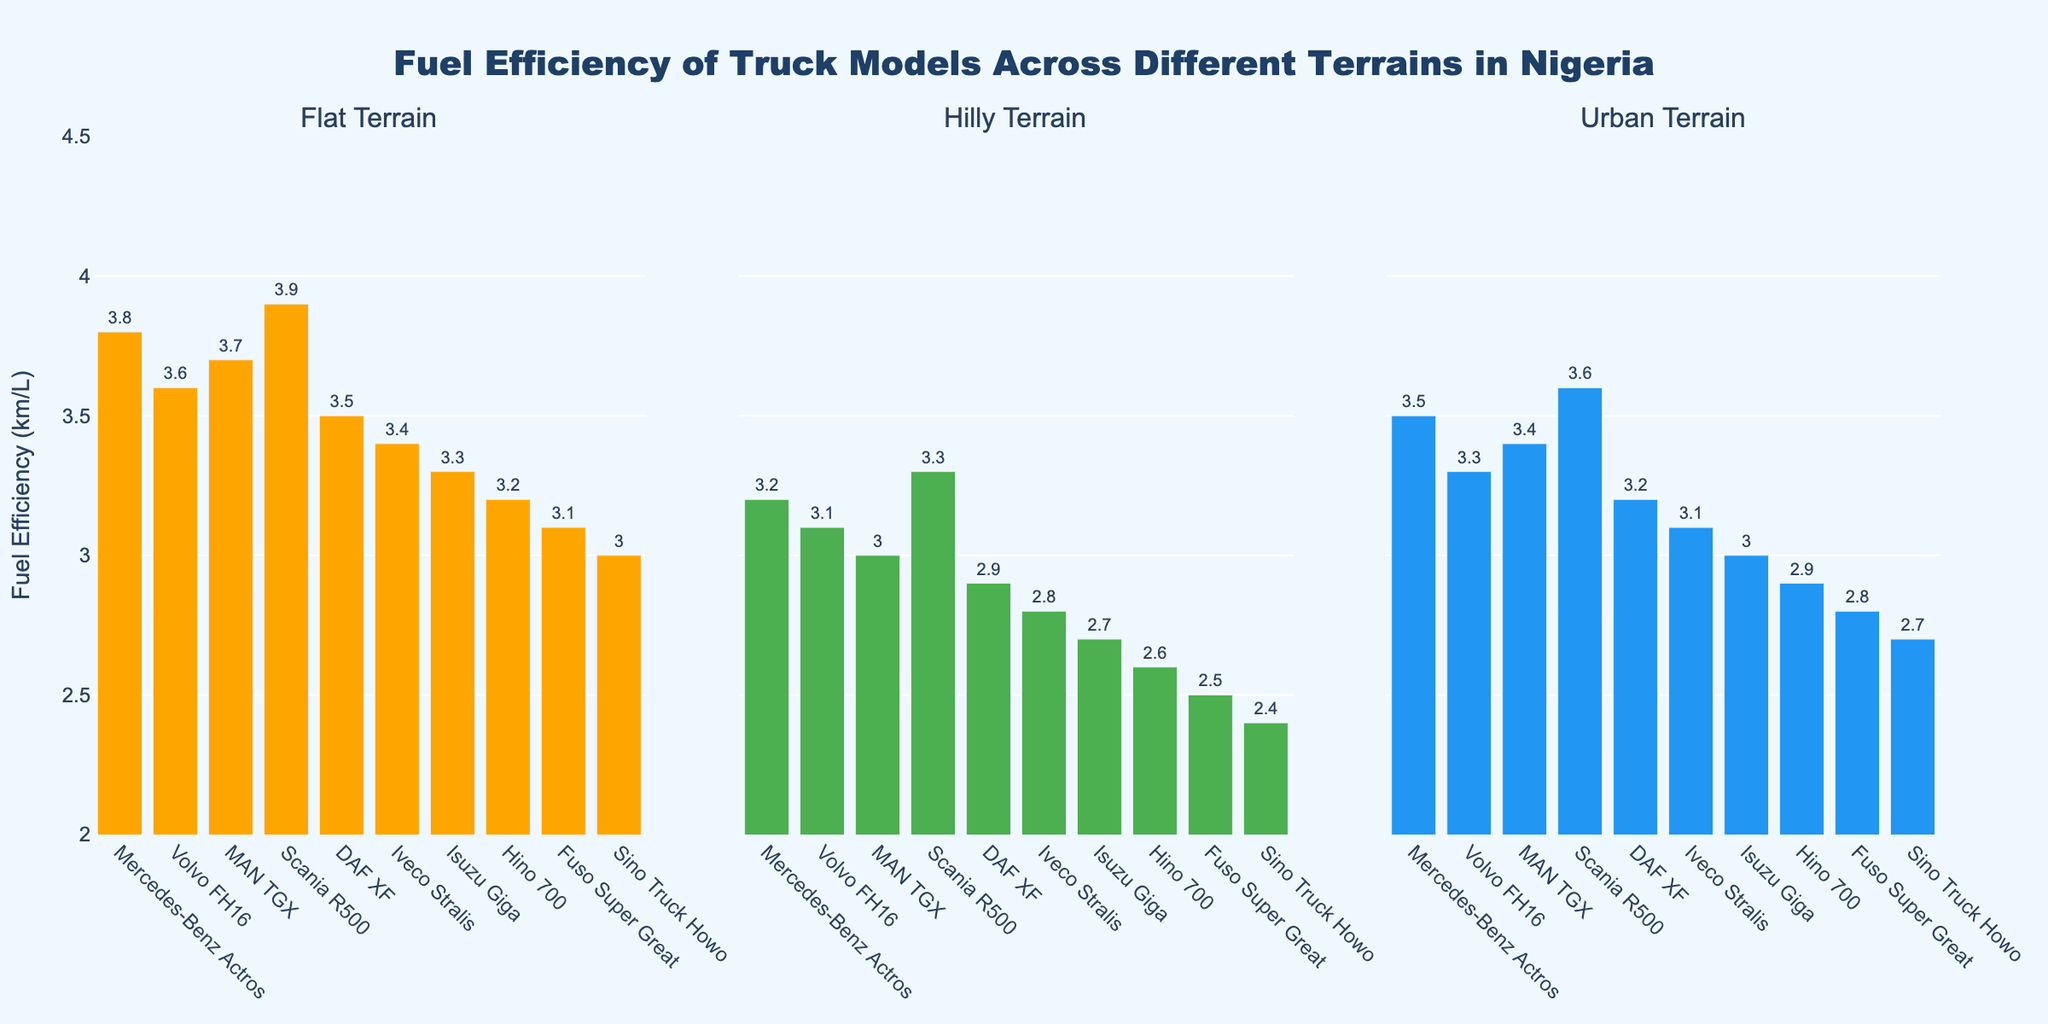What's the fuel efficiency of the Mercedes-Benz Actros on flat terrain? The bar for the Mercedes-Benz Actros under 'Flat Terrain' shows a value of 3.8 km/L.
Answer: 3.8 km/L Which truck model has the highest fuel efficiency on hilly terrain? The tallest bar in the 'Hilly Terrain' subplot belongs to the Scania R500, which has a fuel efficiency of 3.3 km/L.
Answer: Scania R500 What is the difference in fuel efficiency between Fuso Super Great and Sino Truck Howo on flat terrain? The Fuso Super Great has a fuel efficiency of 3.1 km/L and the Sino Truck Howo has 3.0 km/L, so the difference is 3.1 - 3.0.
Answer: 0.1 km/L Which terrain shows the least variation in fuel efficiencies among all truck models? All three subplots show bars of various heights. Comparing the bar heights across subplots, the 'Urban Terrain' shows a narrower range (from 2.7 to 3.6 km/L), indicating the least variation.
Answer: Urban Terrain On which terrain does the Volvo FH16 have the lowest fuel efficiency? The bar for the Volvo FH16 is lowest in the 'Hilly Terrain' subplot at 3.1 km/L, compared to its values in flat and urban terrains.
Answer: Hilly Terrain Are there any truck models with a consistent decrease in fuel efficiency from flat to hilly to urban terrains? Reviewing the bars across all subplots, the Fuso Super Great shows a consistent decrease in fuel efficiency from flat (3.1 km/L) to hilly (2.5 km/L) to urban (2.8 km/L) terrains.
Answer: Yes, Fuso Super Great What's the average fuel efficiency of the MAN TGX across all terrains? The fuel efficiencies for the MAN TGX are 3.7 (flat), 3.0 (hilly), and 3.4 (urban). The average is (3.7 + 3.0 + 3.4) / 3.
Answer: 3.37 km/L Which truck model performs best on urban terrain? The tallest bar in the 'Urban Terrain' subplot belongs to the Scania R500, indicating it has the highest fuel efficiency on urban terrain at 3.6 km/L.
Answer: Scania R500 By how much does the fuel efficiency of DAF XF decrease when moving from flat terrain to hilly terrain? The fuel efficiency of DAF XF is 3.5 km/L on flat terrain and 2.9 km/L on hilly terrain. The decrease is 3.5 - 2.9.
Answer: 0.6 km/L Among all models, which truck has the lowest fuel efficiency on any terrain, and what is that value? The Sino Truck Howo has the lowest bar in the 'Hilly Terrain' subplot at 2.4 km/L, which is the lowest value among all terrains and models.
Answer: Sino Truck Howo, 2.4 km/L 